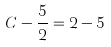Convert formula to latex. <formula><loc_0><loc_0><loc_500><loc_500>C - \frac { 5 } { 2 } = 2 - 5</formula> 